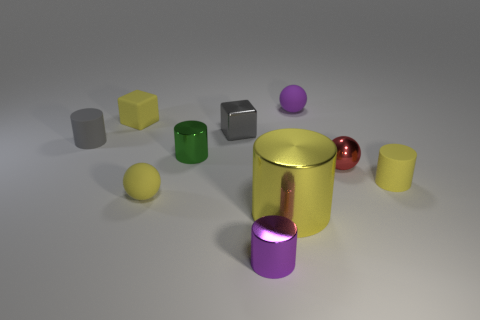What can you deduce about the lighting in this scene? The scene is illuminated by a soft and diffused light source, likely positioned above, as indicated by the gentle shadows cast by the objects. Is there anything in the image that seems to reflect light more than others? Yes, the shiny surfaces, such as the gold cylinder and the silver cube, reflect light strongly, while the matte surfaces, like the balls, have a more subdued reflection. 